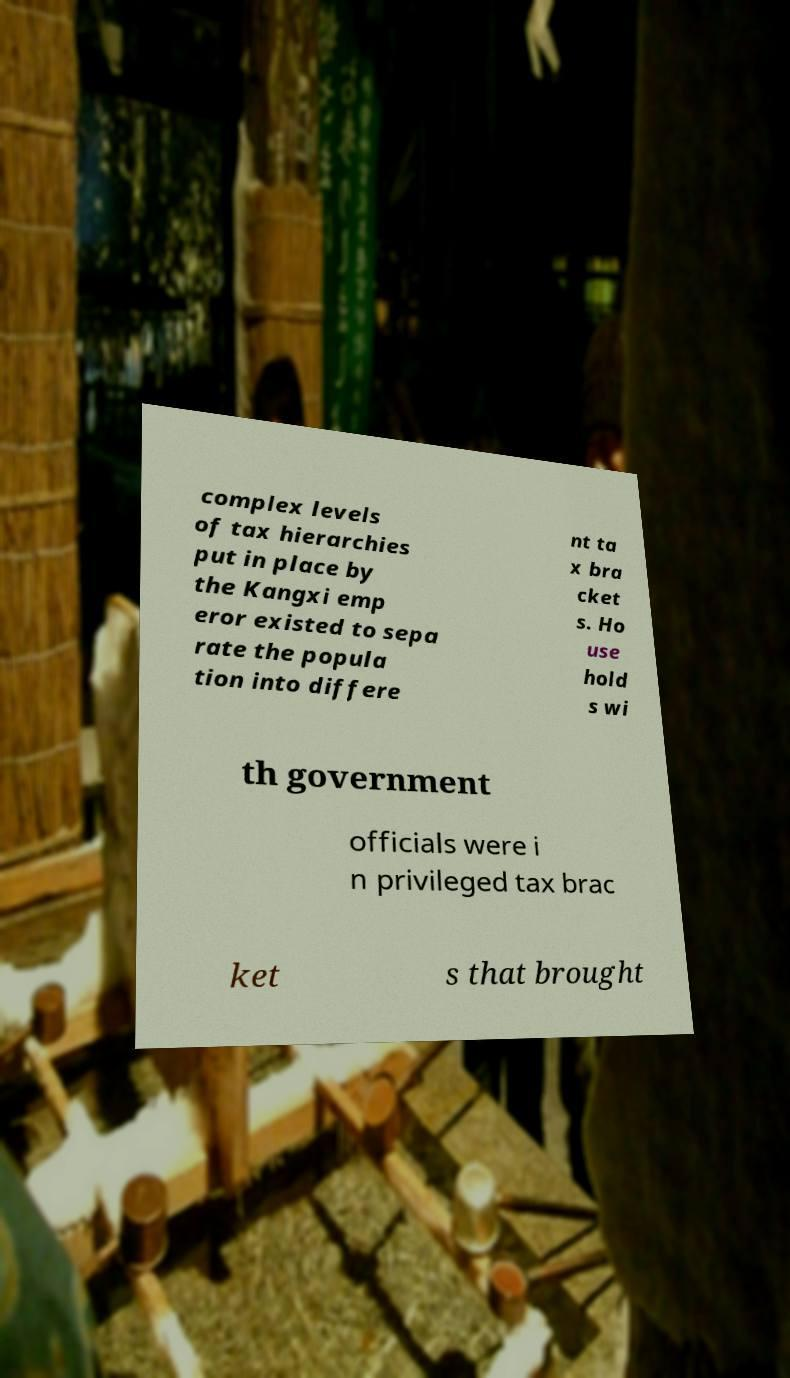I need the written content from this picture converted into text. Can you do that? complex levels of tax hierarchies put in place by the Kangxi emp eror existed to sepa rate the popula tion into differe nt ta x bra cket s. Ho use hold s wi th government officials were i n privileged tax brac ket s that brought 